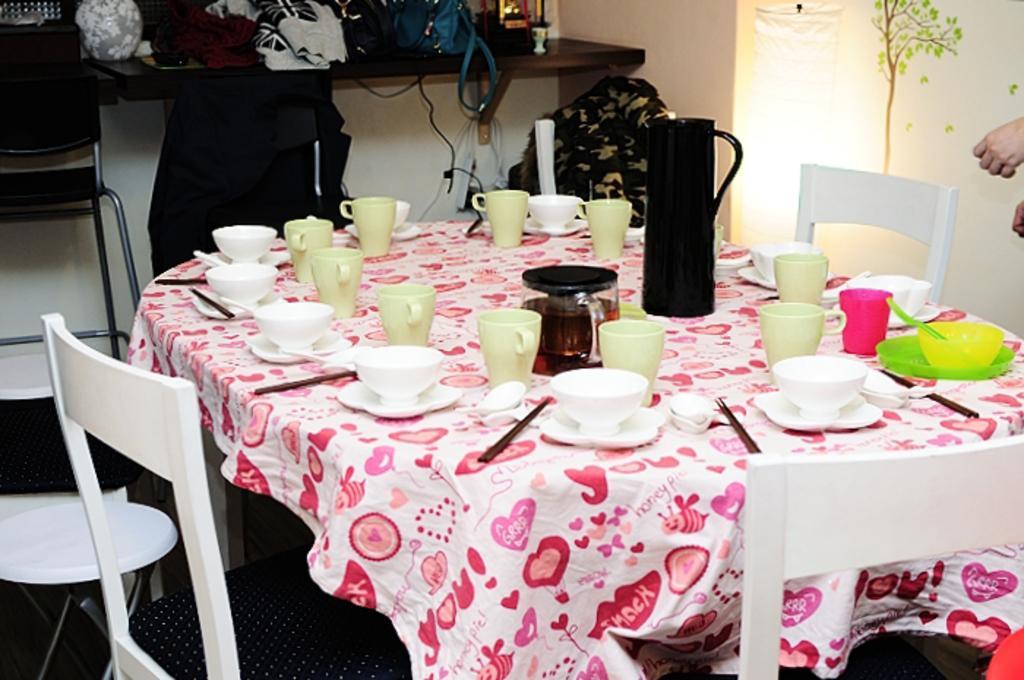How would you summarize this image in a sentence or two? In the image we can see on the dining table there are cups and saucer, there is a jug, there is a bowl and plate and there is a spoon kept in a bowl. Behind on the wall there is a painting of the tree, there are hands of person and on the table there are jacket, purse and beside there is a chair. 